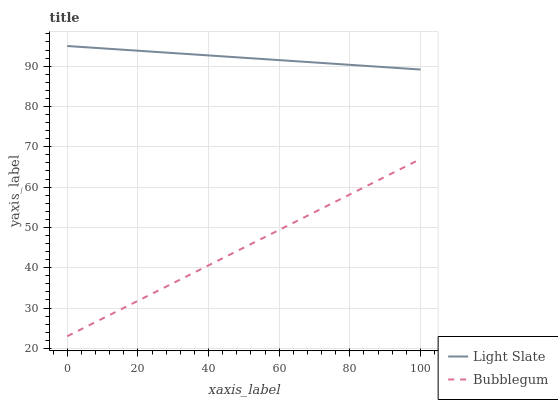Does Bubblegum have the minimum area under the curve?
Answer yes or no. Yes. Does Light Slate have the maximum area under the curve?
Answer yes or no. Yes. Does Bubblegum have the maximum area under the curve?
Answer yes or no. No. Is Bubblegum the smoothest?
Answer yes or no. Yes. Is Light Slate the roughest?
Answer yes or no. Yes. Is Bubblegum the roughest?
Answer yes or no. No. Does Bubblegum have the lowest value?
Answer yes or no. Yes. Does Light Slate have the highest value?
Answer yes or no. Yes. Does Bubblegum have the highest value?
Answer yes or no. No. Is Bubblegum less than Light Slate?
Answer yes or no. Yes. Is Light Slate greater than Bubblegum?
Answer yes or no. Yes. Does Bubblegum intersect Light Slate?
Answer yes or no. No. 